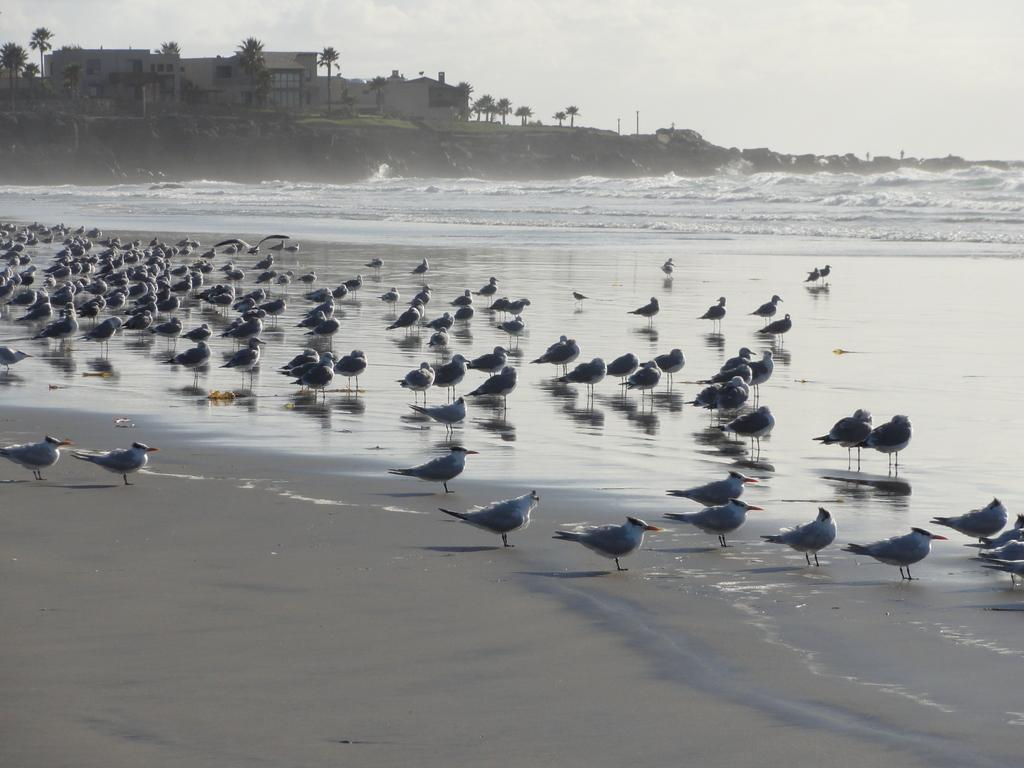What type of animals can be seen in the image? There are birds in the image. Where are the birds located in the image? The birds are standing in the beach. What natural feature is visible in the image? There is an ocean visible in the image. What can be seen in the background of the image? There are trees and a building in the background of the image. What part of the sky is visible in the image? The sky is visible in the image. What type of dinner is being served in the image? There is no dinner or any food visible in the image; it features birds standing in the beach near an ocean. 